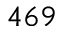<formula> <loc_0><loc_0><loc_500><loc_500>4 6 9</formula> 